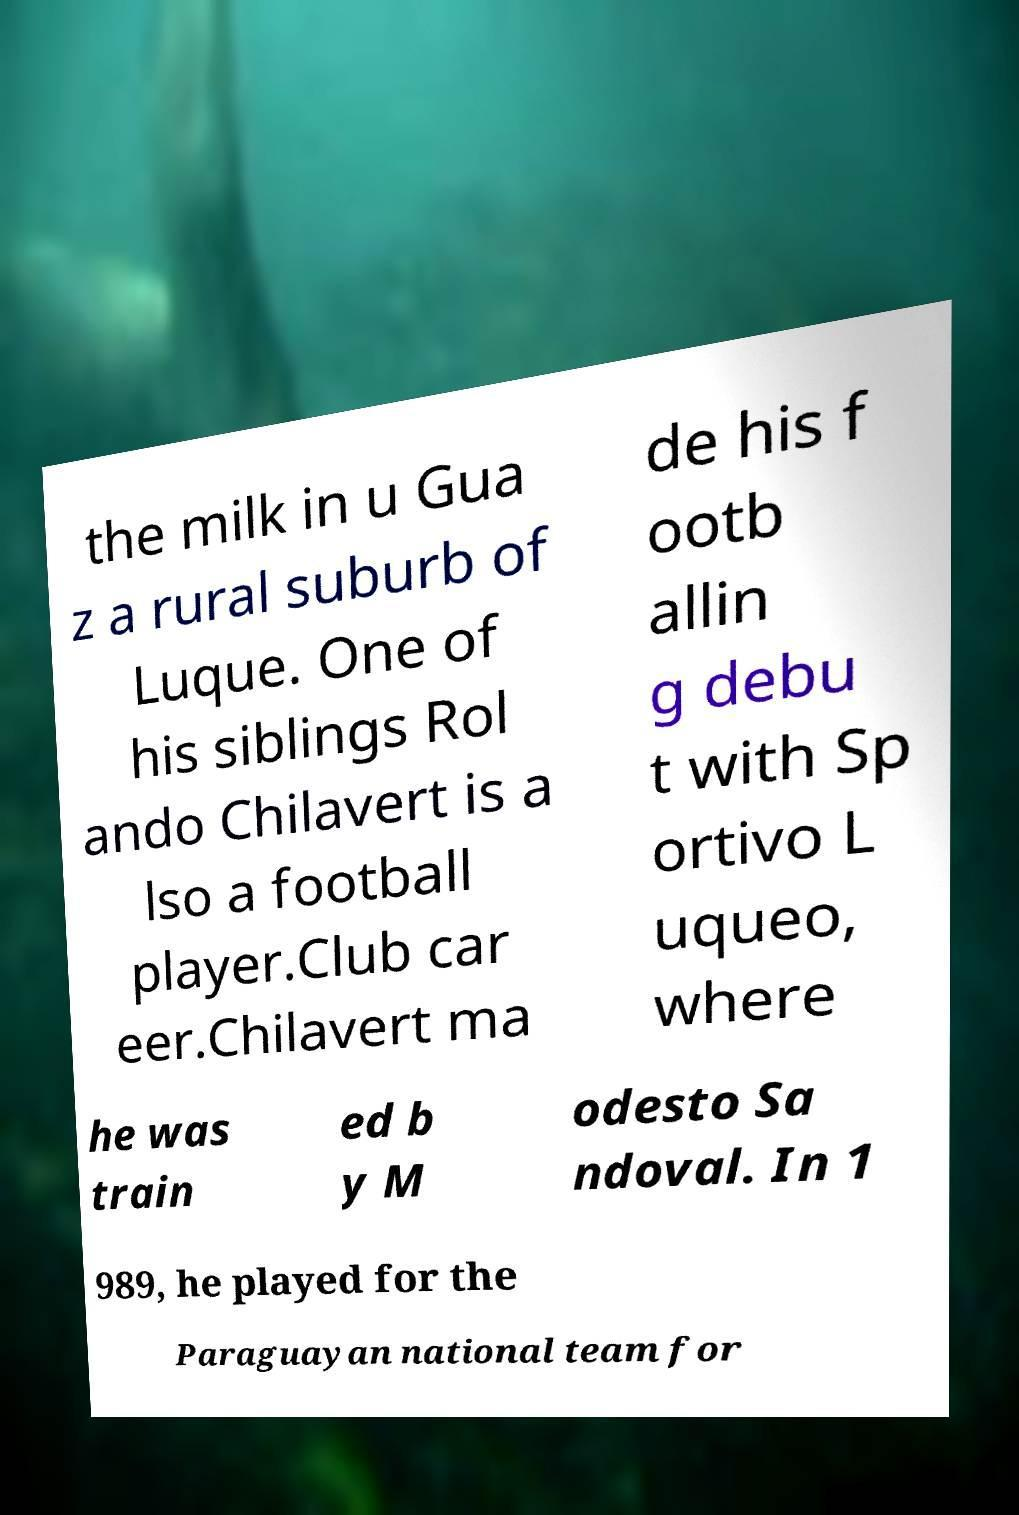Please identify and transcribe the text found in this image. the milk in u Gua z a rural suburb of Luque. One of his siblings Rol ando Chilavert is a lso a football player.Club car eer.Chilavert ma de his f ootb allin g debu t with Sp ortivo L uqueo, where he was train ed b y M odesto Sa ndoval. In 1 989, he played for the Paraguayan national team for 